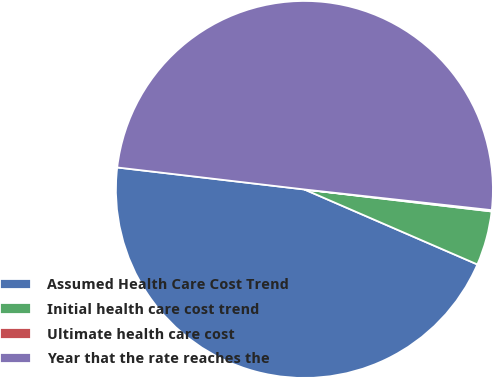<chart> <loc_0><loc_0><loc_500><loc_500><pie_chart><fcel>Assumed Health Care Cost Trend<fcel>Initial health care cost trend<fcel>Ultimate health care cost<fcel>Year that the rate reaches the<nl><fcel>45.35%<fcel>4.65%<fcel>0.11%<fcel>49.89%<nl></chart> 